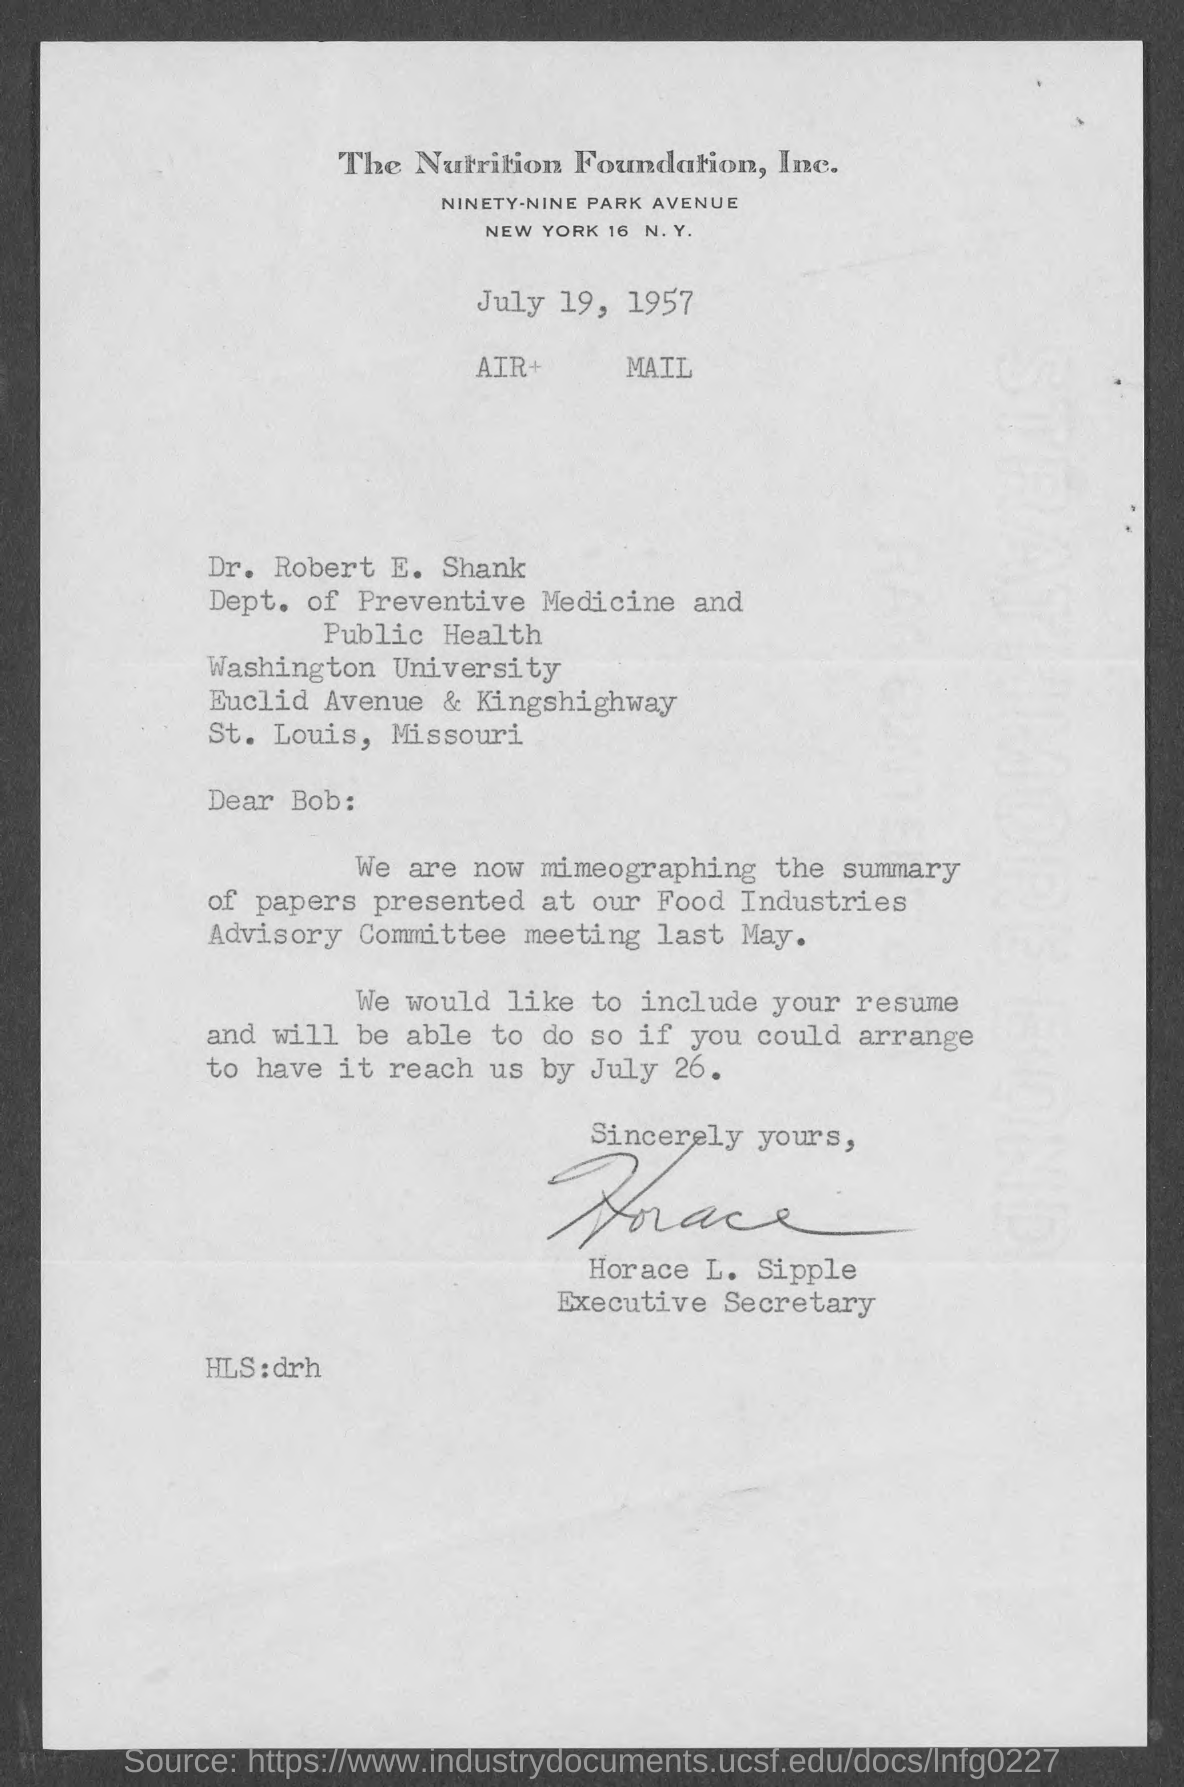Who's sign was there at the end of the letter ?
Your answer should be compact. Horace L. Sipple. What is the designation of horace l. sipple ?
Provide a short and direct response. Executive secretary. To which department dr. robert e. shank belongs to ?
Your response must be concise. Dept. of preventive medicine and public health. To which university dr. robert e. shank belongs to ?
Provide a succinct answer. Washington University. 